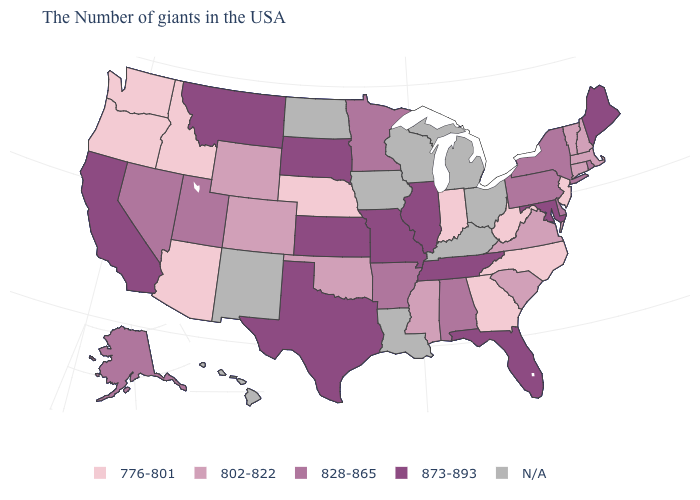What is the value of Ohio?
Write a very short answer. N/A. Which states hav the highest value in the Northeast?
Answer briefly. Maine. What is the value of Iowa?
Answer briefly. N/A. Which states have the highest value in the USA?
Keep it brief. Maine, Maryland, Florida, Tennessee, Illinois, Missouri, Kansas, Texas, South Dakota, Montana, California. Which states hav the highest value in the Northeast?
Short answer required. Maine. What is the value of Wisconsin?
Keep it brief. N/A. What is the lowest value in states that border Tennessee?
Answer briefly. 776-801. What is the value of Alabama?
Keep it brief. 828-865. Name the states that have a value in the range 873-893?
Write a very short answer. Maine, Maryland, Florida, Tennessee, Illinois, Missouri, Kansas, Texas, South Dakota, Montana, California. Does Utah have the highest value in the West?
Give a very brief answer. No. What is the lowest value in the MidWest?
Answer briefly. 776-801. What is the value of Kansas?
Be succinct. 873-893. What is the lowest value in the MidWest?
Be succinct. 776-801. 